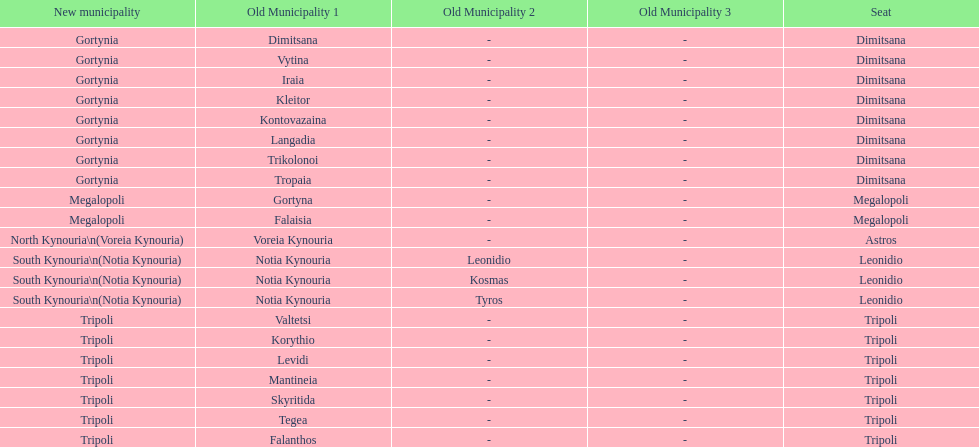Is tripoli still considered a municipality in arcadia since its 2011 reformation? Yes. 